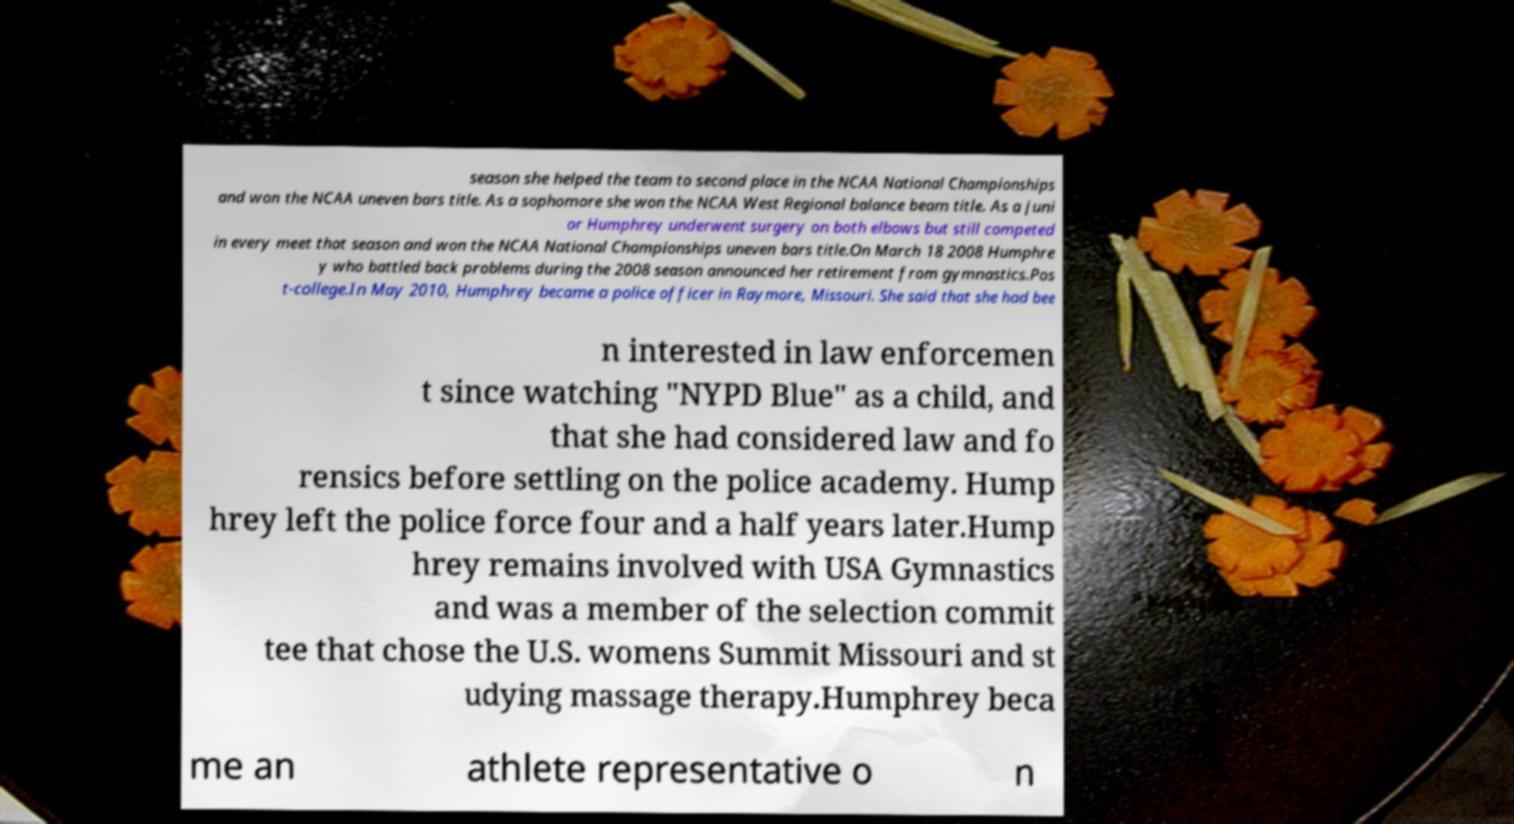Please read and relay the text visible in this image. What does it say? season she helped the team to second place in the NCAA National Championships and won the NCAA uneven bars title. As a sophomore she won the NCAA West Regional balance beam title. As a juni or Humphrey underwent surgery on both elbows but still competed in every meet that season and won the NCAA National Championships uneven bars title.On March 18 2008 Humphre y who battled back problems during the 2008 season announced her retirement from gymnastics.Pos t-college.In May 2010, Humphrey became a police officer in Raymore, Missouri. She said that she had bee n interested in law enforcemen t since watching "NYPD Blue" as a child, and that she had considered law and fo rensics before settling on the police academy. Hump hrey left the police force four and a half years later.Hump hrey remains involved with USA Gymnastics and was a member of the selection commit tee that chose the U.S. womens Summit Missouri and st udying massage therapy.Humphrey beca me an athlete representative o n 